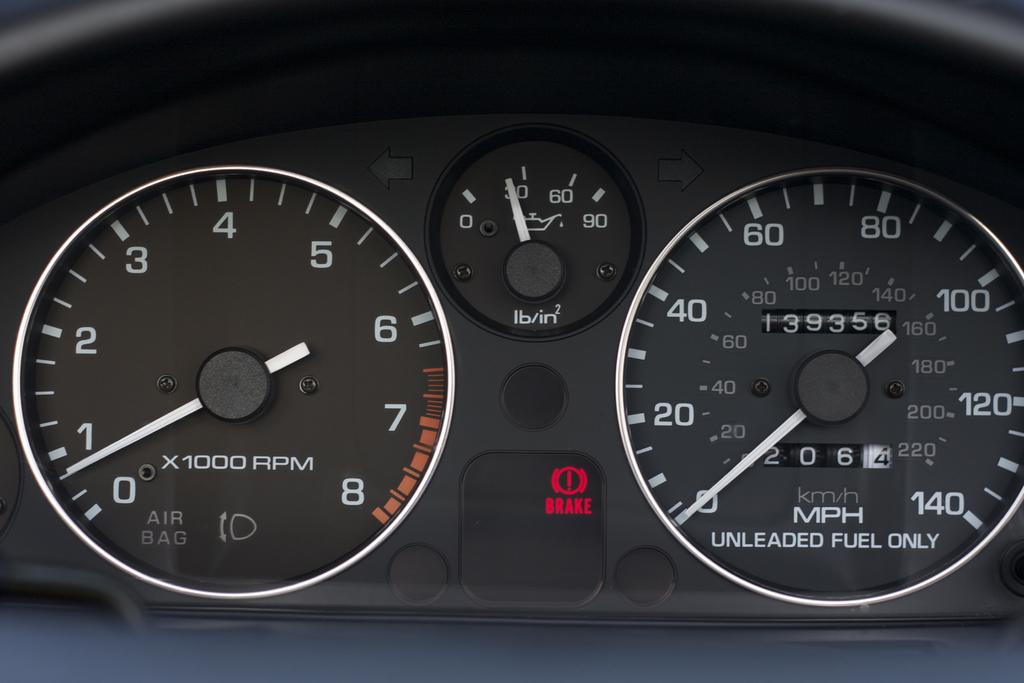What device is visible in the image? There is a speedometer in the image. What is the driver's reaction to the disgusting smell in the image? There is no driver or disgusting smell present in the image; it only features a speedometer. 